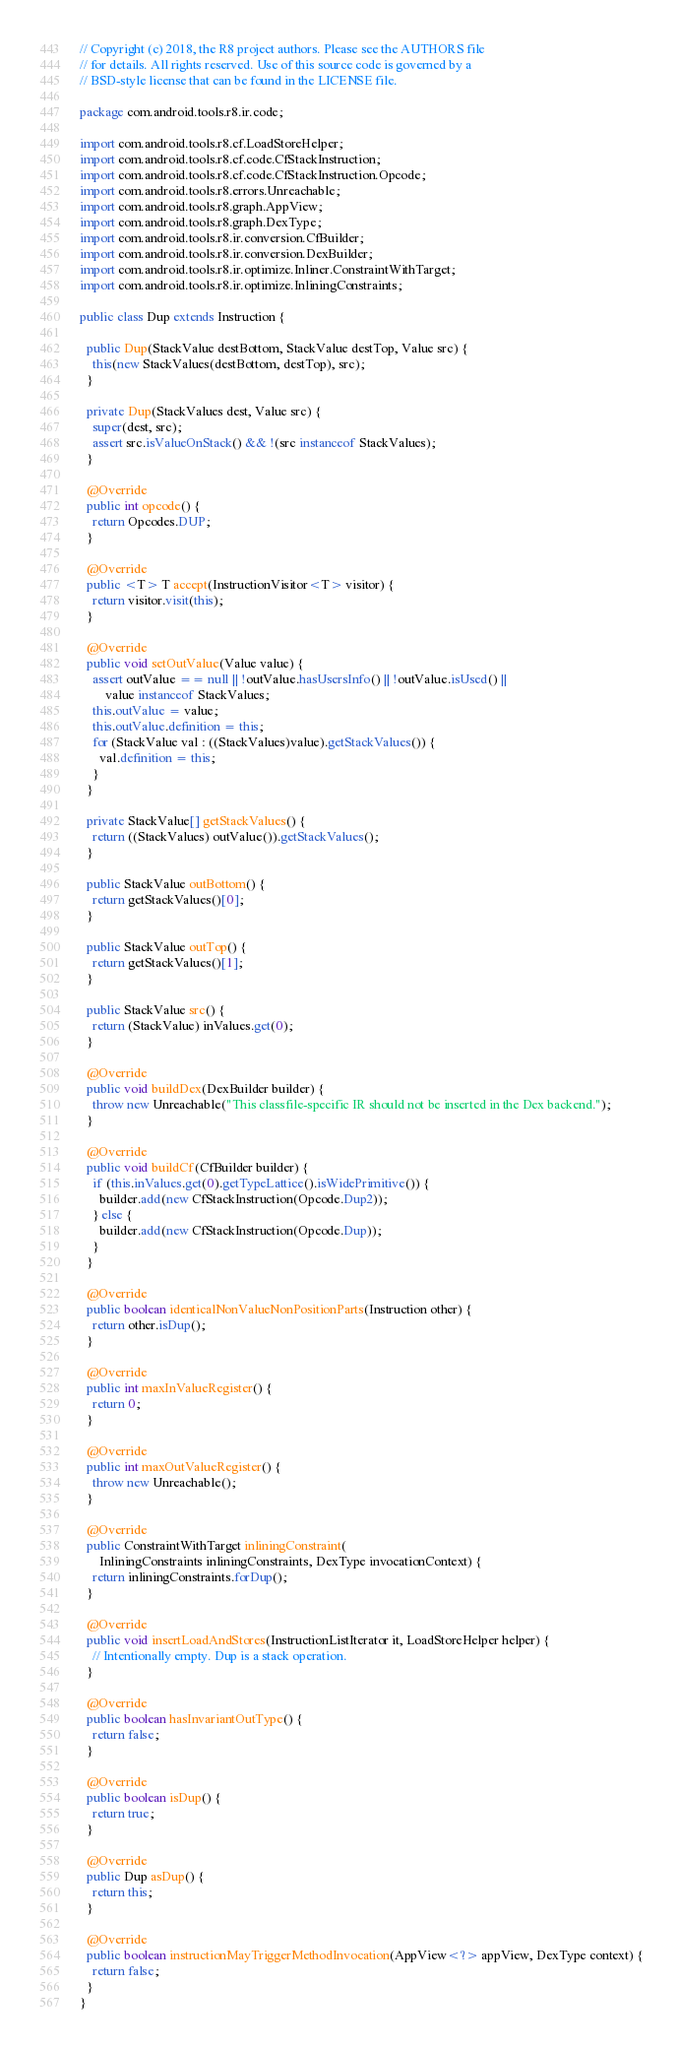Convert code to text. <code><loc_0><loc_0><loc_500><loc_500><_Java_>// Copyright (c) 2018, the R8 project authors. Please see the AUTHORS file
// for details. All rights reserved. Use of this source code is governed by a
// BSD-style license that can be found in the LICENSE file.

package com.android.tools.r8.ir.code;

import com.android.tools.r8.cf.LoadStoreHelper;
import com.android.tools.r8.cf.code.CfStackInstruction;
import com.android.tools.r8.cf.code.CfStackInstruction.Opcode;
import com.android.tools.r8.errors.Unreachable;
import com.android.tools.r8.graph.AppView;
import com.android.tools.r8.graph.DexType;
import com.android.tools.r8.ir.conversion.CfBuilder;
import com.android.tools.r8.ir.conversion.DexBuilder;
import com.android.tools.r8.ir.optimize.Inliner.ConstraintWithTarget;
import com.android.tools.r8.ir.optimize.InliningConstraints;

public class Dup extends Instruction {

  public Dup(StackValue destBottom, StackValue destTop, Value src) {
    this(new StackValues(destBottom, destTop), src);
  }

  private Dup(StackValues dest, Value src) {
    super(dest, src);
    assert src.isValueOnStack() && !(src instanceof StackValues);
  }

  @Override
  public int opcode() {
    return Opcodes.DUP;
  }

  @Override
  public <T> T accept(InstructionVisitor<T> visitor) {
    return visitor.visit(this);
  }

  @Override
  public void setOutValue(Value value) {
    assert outValue == null || !outValue.hasUsersInfo() || !outValue.isUsed() ||
        value instanceof StackValues;
    this.outValue = value;
    this.outValue.definition = this;
    for (StackValue val : ((StackValues)value).getStackValues()) {
      val.definition = this;
    }
  }

  private StackValue[] getStackValues() {
    return ((StackValues) outValue()).getStackValues();
  }

  public StackValue outBottom() {
    return getStackValues()[0];
  }

  public StackValue outTop() {
    return getStackValues()[1];
  }

  public StackValue src() {
    return (StackValue) inValues.get(0);
  }

  @Override
  public void buildDex(DexBuilder builder) {
    throw new Unreachable("This classfile-specific IR should not be inserted in the Dex backend.");
  }

  @Override
  public void buildCf(CfBuilder builder) {
    if (this.inValues.get(0).getTypeLattice().isWidePrimitive()) {
      builder.add(new CfStackInstruction(Opcode.Dup2));
    } else {
      builder.add(new CfStackInstruction(Opcode.Dup));
    }
  }

  @Override
  public boolean identicalNonValueNonPositionParts(Instruction other) {
    return other.isDup();
  }

  @Override
  public int maxInValueRegister() {
    return 0;
  }

  @Override
  public int maxOutValueRegister() {
    throw new Unreachable();
  }

  @Override
  public ConstraintWithTarget inliningConstraint(
      InliningConstraints inliningConstraints, DexType invocationContext) {
    return inliningConstraints.forDup();
  }

  @Override
  public void insertLoadAndStores(InstructionListIterator it, LoadStoreHelper helper) {
    // Intentionally empty. Dup is a stack operation.
  }

  @Override
  public boolean hasInvariantOutType() {
    return false;
  }

  @Override
  public boolean isDup() {
    return true;
  }

  @Override
  public Dup asDup() {
    return this;
  }

  @Override
  public boolean instructionMayTriggerMethodInvocation(AppView<?> appView, DexType context) {
    return false;
  }
}
</code> 